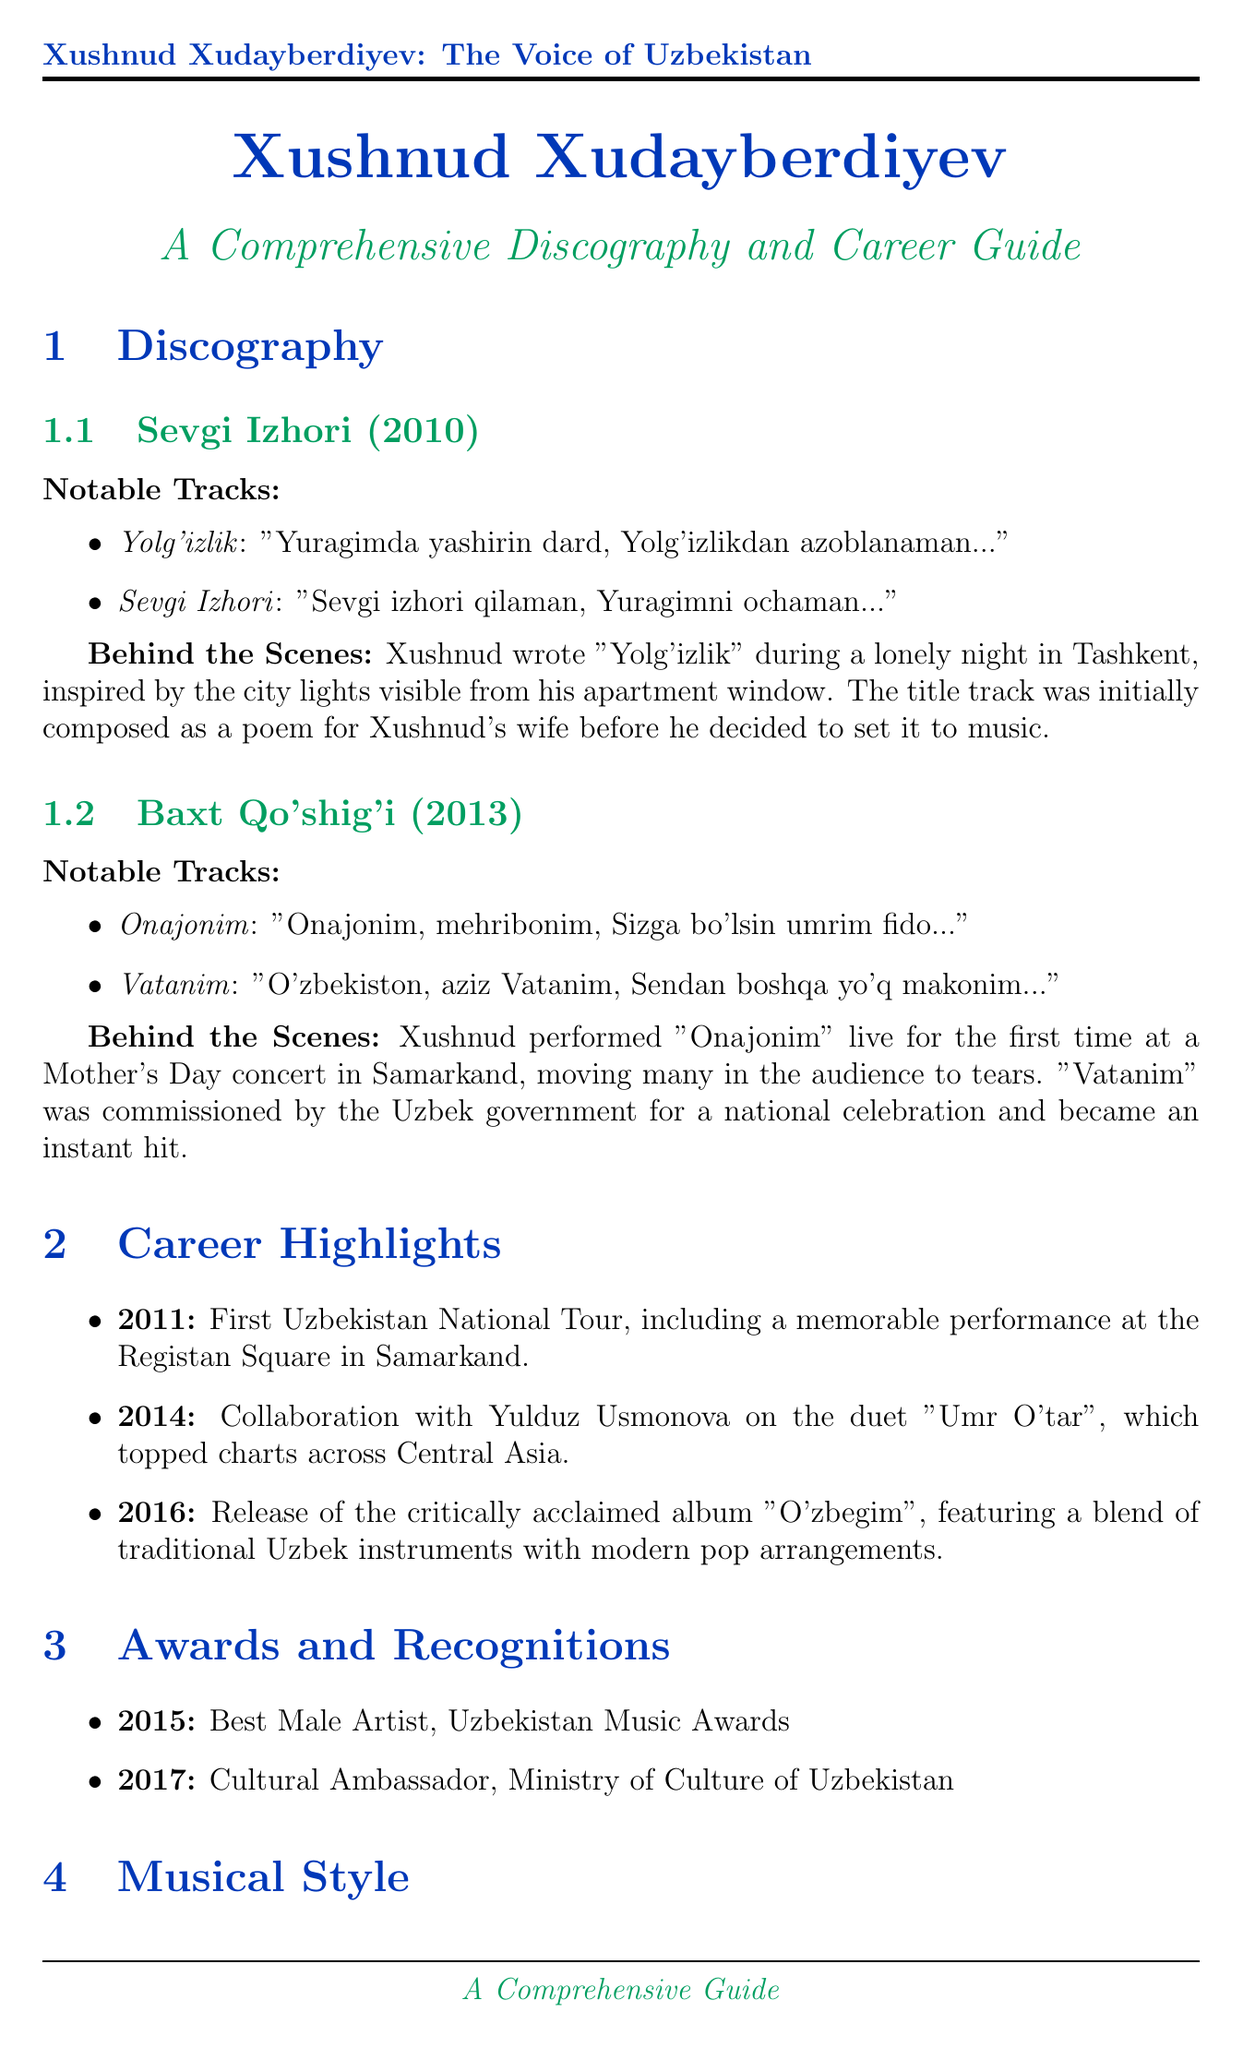What is the title of Xushnud Xudayberdiyev's first album? The first album listed in the discography is "Sevgi Izhori."
Answer: Sevgi Izhori In what year was the album "Baxt Qo'shig'i" released? The year the album "Baxt Qo'shig'i" was released is indicated in the document.
Answer: 2013 What is the cover URL for the album "O'zbegim"? The document provides the cover URL for the album "O'zbegim," which is listed in the career highlights.
Answer: https://example.com/ozbegim_cover.jpg Who did Xushnud collaborate with for the song "Umr O'tar"? The collaboration for the song "Umr O'tar" is mentioned in the career highlights section.
Answer: Yulduz Usmonova What genre does Xushnud's music mainly belong to? The musical style section lists the genres associated with Xushnud Xudayberdiyev's music.
Answer: Pop What was the notable event in Xushnud's career in 2011? The career highlights outline several events, including one from 2011.
Answer: First Uzbekistan National Tour How many children does Xushnud have? The personal life section states the number of children he has.
Answer: Two children What is the expected release date for the album "Yangi Kun"? The upcoming projects section specifies the expected release timeframe for the album.
Answer: Fall 2023 What is the title of the documentary about Xushnud? The upcoming projects section mentions the title of the documentary.
Answer: Xushnud: The Voice of Modern Uzbekistan 